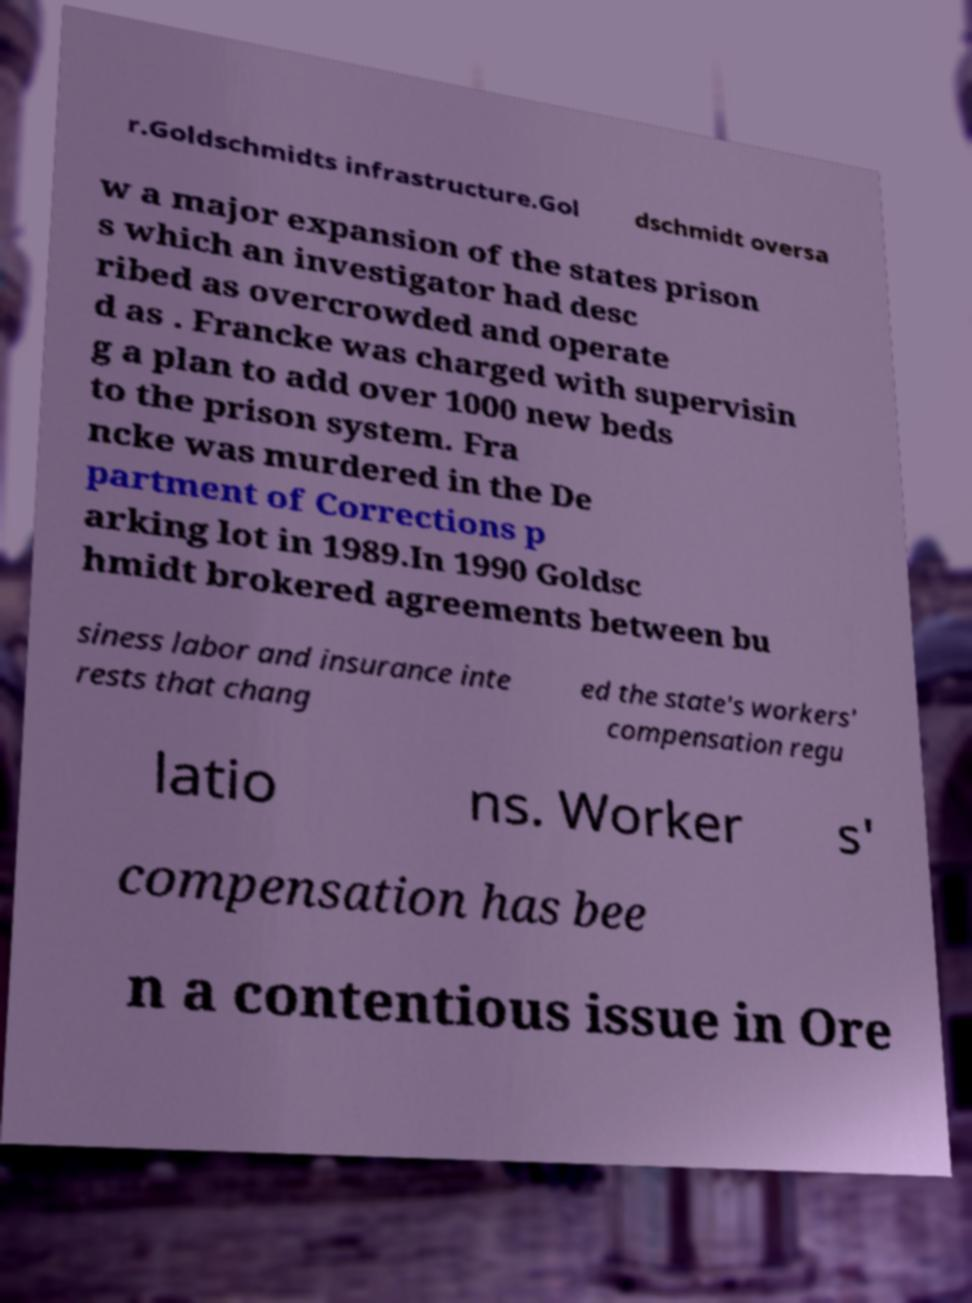Can you accurately transcribe the text from the provided image for me? r.Goldschmidts infrastructure.Gol dschmidt oversa w a major expansion of the states prison s which an investigator had desc ribed as overcrowded and operate d as . Francke was charged with supervisin g a plan to add over 1000 new beds to the prison system. Fra ncke was murdered in the De partment of Corrections p arking lot in 1989.In 1990 Goldsc hmidt brokered agreements between bu siness labor and insurance inte rests that chang ed the state's workers' compensation regu latio ns. Worker s' compensation has bee n a contentious issue in Ore 